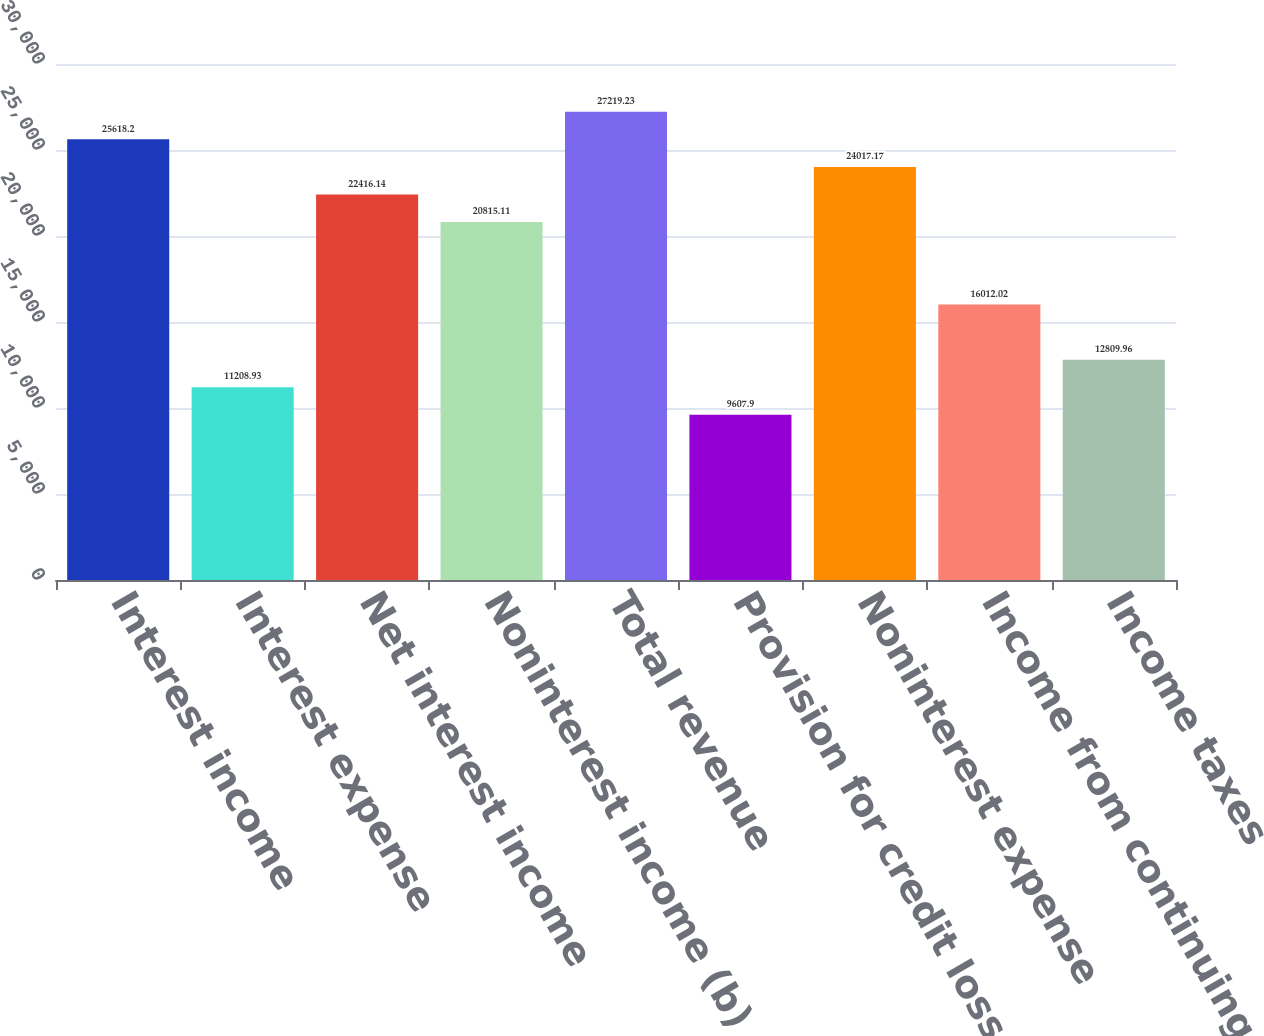Convert chart. <chart><loc_0><loc_0><loc_500><loc_500><bar_chart><fcel>Interest income<fcel>Interest expense<fcel>Net interest income<fcel>Noninterest income (b)<fcel>Total revenue<fcel>Provision for credit losses<fcel>Noninterest expense<fcel>Income from continuing<fcel>Income taxes<nl><fcel>25618.2<fcel>11208.9<fcel>22416.1<fcel>20815.1<fcel>27219.2<fcel>9607.9<fcel>24017.2<fcel>16012<fcel>12810<nl></chart> 